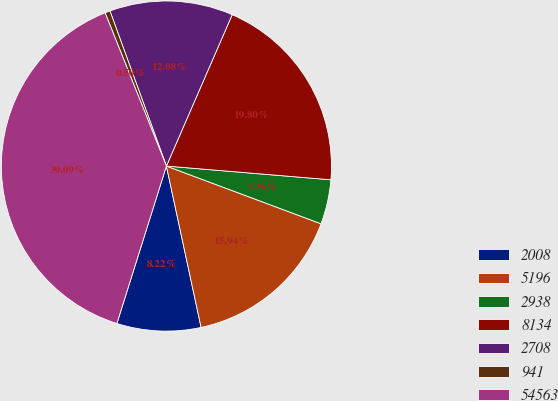Convert chart to OTSL. <chart><loc_0><loc_0><loc_500><loc_500><pie_chart><fcel>2008<fcel>5196<fcel>2938<fcel>8134<fcel>2708<fcel>941<fcel>54563<nl><fcel>8.22%<fcel>15.94%<fcel>4.36%<fcel>19.8%<fcel>12.08%<fcel>0.5%<fcel>39.09%<nl></chart> 